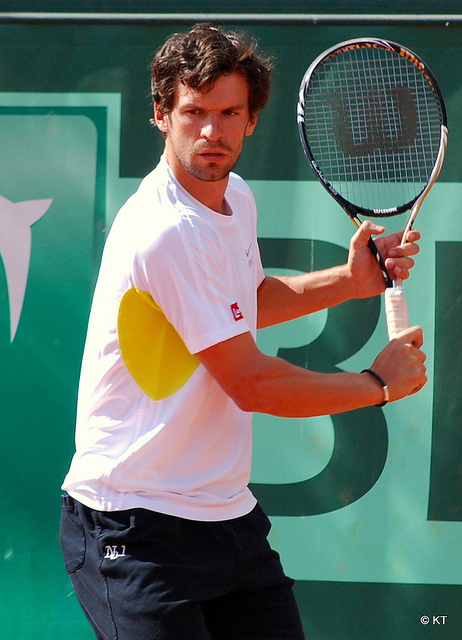Read and extract the text from this image. KT 